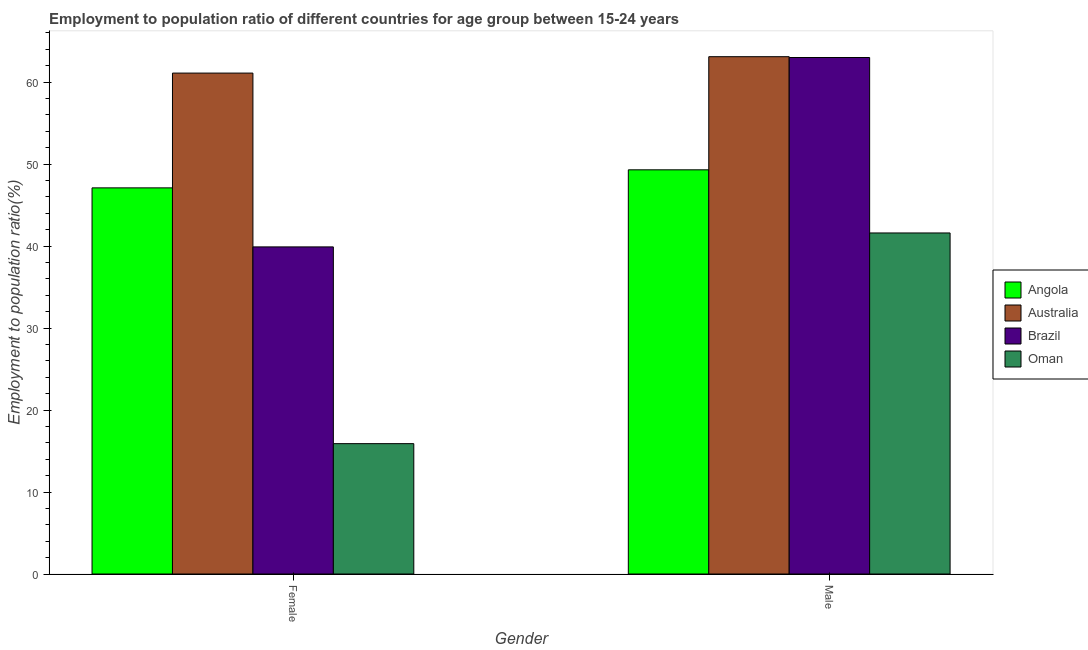Are the number of bars on each tick of the X-axis equal?
Your response must be concise. Yes. How many bars are there on the 2nd tick from the left?
Offer a terse response. 4. How many bars are there on the 2nd tick from the right?
Offer a terse response. 4. What is the label of the 2nd group of bars from the left?
Keep it short and to the point. Male. What is the employment to population ratio(female) in Brazil?
Provide a short and direct response. 39.9. Across all countries, what is the maximum employment to population ratio(male)?
Offer a terse response. 63.1. Across all countries, what is the minimum employment to population ratio(female)?
Provide a short and direct response. 15.9. In which country was the employment to population ratio(male) maximum?
Ensure brevity in your answer.  Australia. In which country was the employment to population ratio(male) minimum?
Provide a short and direct response. Oman. What is the total employment to population ratio(male) in the graph?
Ensure brevity in your answer.  217. What is the difference between the employment to population ratio(female) in Angola and that in Australia?
Make the answer very short. -14. What is the difference between the employment to population ratio(female) in Oman and the employment to population ratio(male) in Angola?
Offer a very short reply. -33.4. What is the average employment to population ratio(male) per country?
Provide a succinct answer. 54.25. What is the difference between the employment to population ratio(male) and employment to population ratio(female) in Angola?
Give a very brief answer. 2.2. What is the ratio of the employment to population ratio(male) in Australia to that in Oman?
Provide a succinct answer. 1.52. Is the employment to population ratio(female) in Brazil less than that in Oman?
Offer a very short reply. No. In how many countries, is the employment to population ratio(female) greater than the average employment to population ratio(female) taken over all countries?
Your answer should be compact. 2. What does the 2nd bar from the left in Female represents?
Give a very brief answer. Australia. How many bars are there?
Your answer should be compact. 8. How many countries are there in the graph?
Provide a succinct answer. 4. What is the difference between two consecutive major ticks on the Y-axis?
Give a very brief answer. 10. Are the values on the major ticks of Y-axis written in scientific E-notation?
Ensure brevity in your answer.  No. Does the graph contain grids?
Offer a very short reply. No. Where does the legend appear in the graph?
Your answer should be compact. Center right. How many legend labels are there?
Make the answer very short. 4. What is the title of the graph?
Provide a succinct answer. Employment to population ratio of different countries for age group between 15-24 years. Does "Kosovo" appear as one of the legend labels in the graph?
Provide a short and direct response. No. What is the Employment to population ratio(%) in Angola in Female?
Provide a succinct answer. 47.1. What is the Employment to population ratio(%) of Australia in Female?
Provide a short and direct response. 61.1. What is the Employment to population ratio(%) in Brazil in Female?
Your response must be concise. 39.9. What is the Employment to population ratio(%) in Oman in Female?
Your answer should be compact. 15.9. What is the Employment to population ratio(%) of Angola in Male?
Your response must be concise. 49.3. What is the Employment to population ratio(%) of Australia in Male?
Keep it short and to the point. 63.1. What is the Employment to population ratio(%) in Brazil in Male?
Offer a terse response. 63. What is the Employment to population ratio(%) of Oman in Male?
Provide a succinct answer. 41.6. Across all Gender, what is the maximum Employment to population ratio(%) of Angola?
Ensure brevity in your answer.  49.3. Across all Gender, what is the maximum Employment to population ratio(%) in Australia?
Ensure brevity in your answer.  63.1. Across all Gender, what is the maximum Employment to population ratio(%) of Brazil?
Offer a very short reply. 63. Across all Gender, what is the maximum Employment to population ratio(%) in Oman?
Ensure brevity in your answer.  41.6. Across all Gender, what is the minimum Employment to population ratio(%) in Angola?
Give a very brief answer. 47.1. Across all Gender, what is the minimum Employment to population ratio(%) of Australia?
Make the answer very short. 61.1. Across all Gender, what is the minimum Employment to population ratio(%) of Brazil?
Offer a terse response. 39.9. Across all Gender, what is the minimum Employment to population ratio(%) in Oman?
Offer a terse response. 15.9. What is the total Employment to population ratio(%) in Angola in the graph?
Give a very brief answer. 96.4. What is the total Employment to population ratio(%) in Australia in the graph?
Keep it short and to the point. 124.2. What is the total Employment to population ratio(%) in Brazil in the graph?
Keep it short and to the point. 102.9. What is the total Employment to population ratio(%) in Oman in the graph?
Give a very brief answer. 57.5. What is the difference between the Employment to population ratio(%) in Angola in Female and that in Male?
Your answer should be compact. -2.2. What is the difference between the Employment to population ratio(%) of Brazil in Female and that in Male?
Offer a terse response. -23.1. What is the difference between the Employment to population ratio(%) of Oman in Female and that in Male?
Your answer should be very brief. -25.7. What is the difference between the Employment to population ratio(%) of Angola in Female and the Employment to population ratio(%) of Brazil in Male?
Your answer should be compact. -15.9. What is the difference between the Employment to population ratio(%) of Angola in Female and the Employment to population ratio(%) of Oman in Male?
Your response must be concise. 5.5. What is the difference between the Employment to population ratio(%) in Australia in Female and the Employment to population ratio(%) in Brazil in Male?
Make the answer very short. -1.9. What is the difference between the Employment to population ratio(%) of Australia in Female and the Employment to population ratio(%) of Oman in Male?
Offer a terse response. 19.5. What is the average Employment to population ratio(%) in Angola per Gender?
Your response must be concise. 48.2. What is the average Employment to population ratio(%) in Australia per Gender?
Offer a very short reply. 62.1. What is the average Employment to population ratio(%) of Brazil per Gender?
Offer a very short reply. 51.45. What is the average Employment to population ratio(%) in Oman per Gender?
Give a very brief answer. 28.75. What is the difference between the Employment to population ratio(%) in Angola and Employment to population ratio(%) in Australia in Female?
Your answer should be very brief. -14. What is the difference between the Employment to population ratio(%) in Angola and Employment to population ratio(%) in Oman in Female?
Offer a terse response. 31.2. What is the difference between the Employment to population ratio(%) in Australia and Employment to population ratio(%) in Brazil in Female?
Keep it short and to the point. 21.2. What is the difference between the Employment to population ratio(%) in Australia and Employment to population ratio(%) in Oman in Female?
Offer a very short reply. 45.2. What is the difference between the Employment to population ratio(%) in Angola and Employment to population ratio(%) in Brazil in Male?
Keep it short and to the point. -13.7. What is the difference between the Employment to population ratio(%) of Australia and Employment to population ratio(%) of Brazil in Male?
Give a very brief answer. 0.1. What is the difference between the Employment to population ratio(%) of Australia and Employment to population ratio(%) of Oman in Male?
Offer a very short reply. 21.5. What is the difference between the Employment to population ratio(%) in Brazil and Employment to population ratio(%) in Oman in Male?
Make the answer very short. 21.4. What is the ratio of the Employment to population ratio(%) of Angola in Female to that in Male?
Your answer should be compact. 0.96. What is the ratio of the Employment to population ratio(%) of Australia in Female to that in Male?
Your response must be concise. 0.97. What is the ratio of the Employment to population ratio(%) of Brazil in Female to that in Male?
Offer a terse response. 0.63. What is the ratio of the Employment to population ratio(%) in Oman in Female to that in Male?
Give a very brief answer. 0.38. What is the difference between the highest and the second highest Employment to population ratio(%) in Australia?
Your answer should be compact. 2. What is the difference between the highest and the second highest Employment to population ratio(%) of Brazil?
Your response must be concise. 23.1. What is the difference between the highest and the second highest Employment to population ratio(%) in Oman?
Provide a succinct answer. 25.7. What is the difference between the highest and the lowest Employment to population ratio(%) of Australia?
Ensure brevity in your answer.  2. What is the difference between the highest and the lowest Employment to population ratio(%) in Brazil?
Provide a short and direct response. 23.1. What is the difference between the highest and the lowest Employment to population ratio(%) of Oman?
Keep it short and to the point. 25.7. 